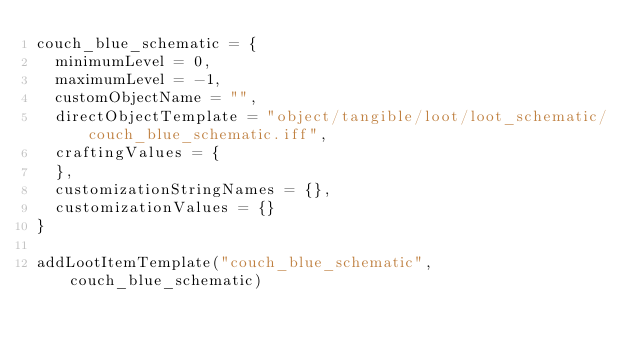Convert code to text. <code><loc_0><loc_0><loc_500><loc_500><_Lua_>couch_blue_schematic = {
	minimumLevel = 0,
	maximumLevel = -1,
	customObjectName = "",
	directObjectTemplate = "object/tangible/loot/loot_schematic/couch_blue_schematic.iff",
	craftingValues = {
	},
	customizationStringNames = {},
	customizationValues = {}
}

addLootItemTemplate("couch_blue_schematic", couch_blue_schematic)
</code> 